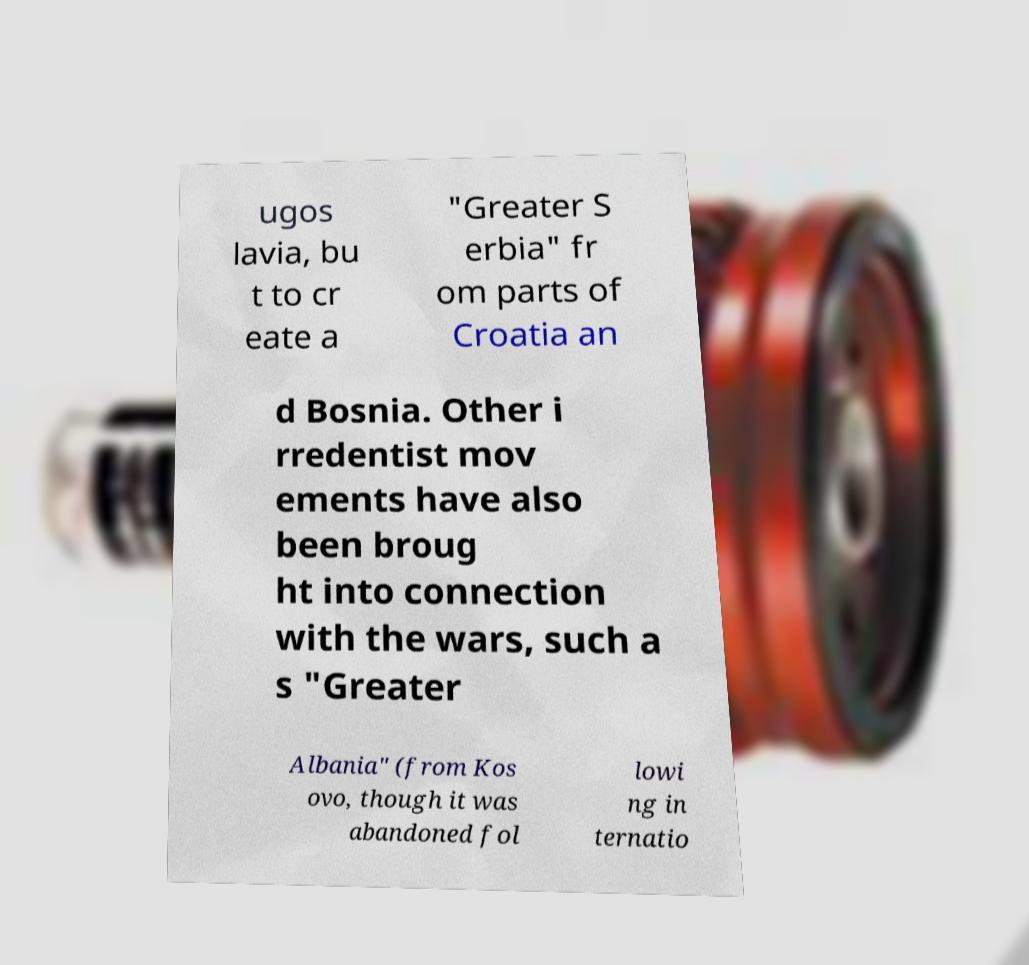Can you accurately transcribe the text from the provided image for me? ugos lavia, bu t to cr eate a "Greater S erbia" fr om parts of Croatia an d Bosnia. Other i rredentist mov ements have also been broug ht into connection with the wars, such a s "Greater Albania" (from Kos ovo, though it was abandoned fol lowi ng in ternatio 